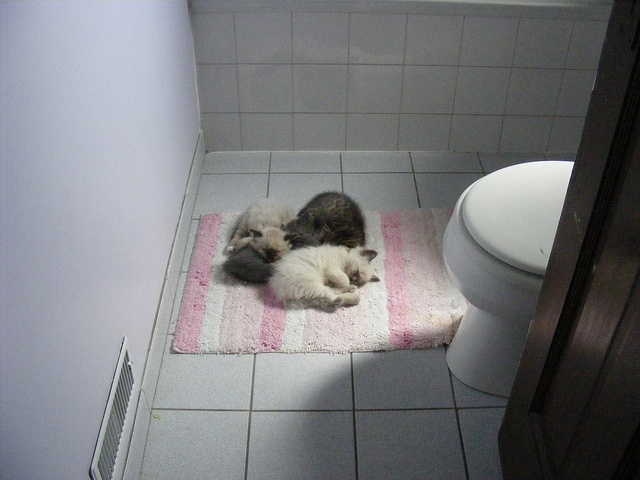Describe the objects in this image and their specific colors. I can see toilet in gray, darkgray, lightgray, and black tones, cat in gray, darkgray, and lightgray tones, cat in gray and black tones, cat in gray, darkgray, and black tones, and cat in gray and black tones in this image. 